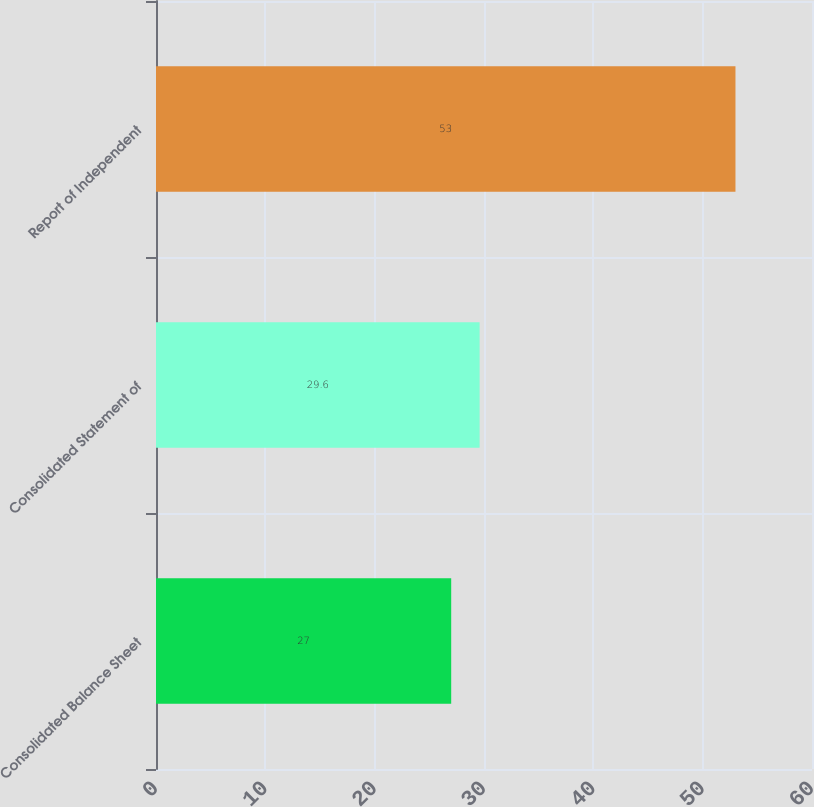Convert chart. <chart><loc_0><loc_0><loc_500><loc_500><bar_chart><fcel>Consolidated Balance Sheet<fcel>Consolidated Statement of<fcel>Report of Independent<nl><fcel>27<fcel>29.6<fcel>53<nl></chart> 